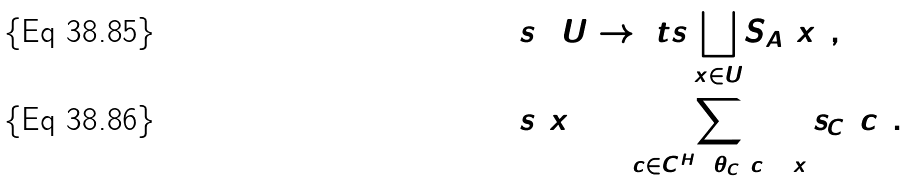<formula> <loc_0><loc_0><loc_500><loc_500>& s \colon U \to { \ t s \bigsqcup _ { x \in U } } S _ { A } ( x ) , \\ & s ( x ) = \sum _ { c \in C ^ { H } \colon \theta _ { C } ( c ) = x } s _ { C } ( c ) .</formula> 